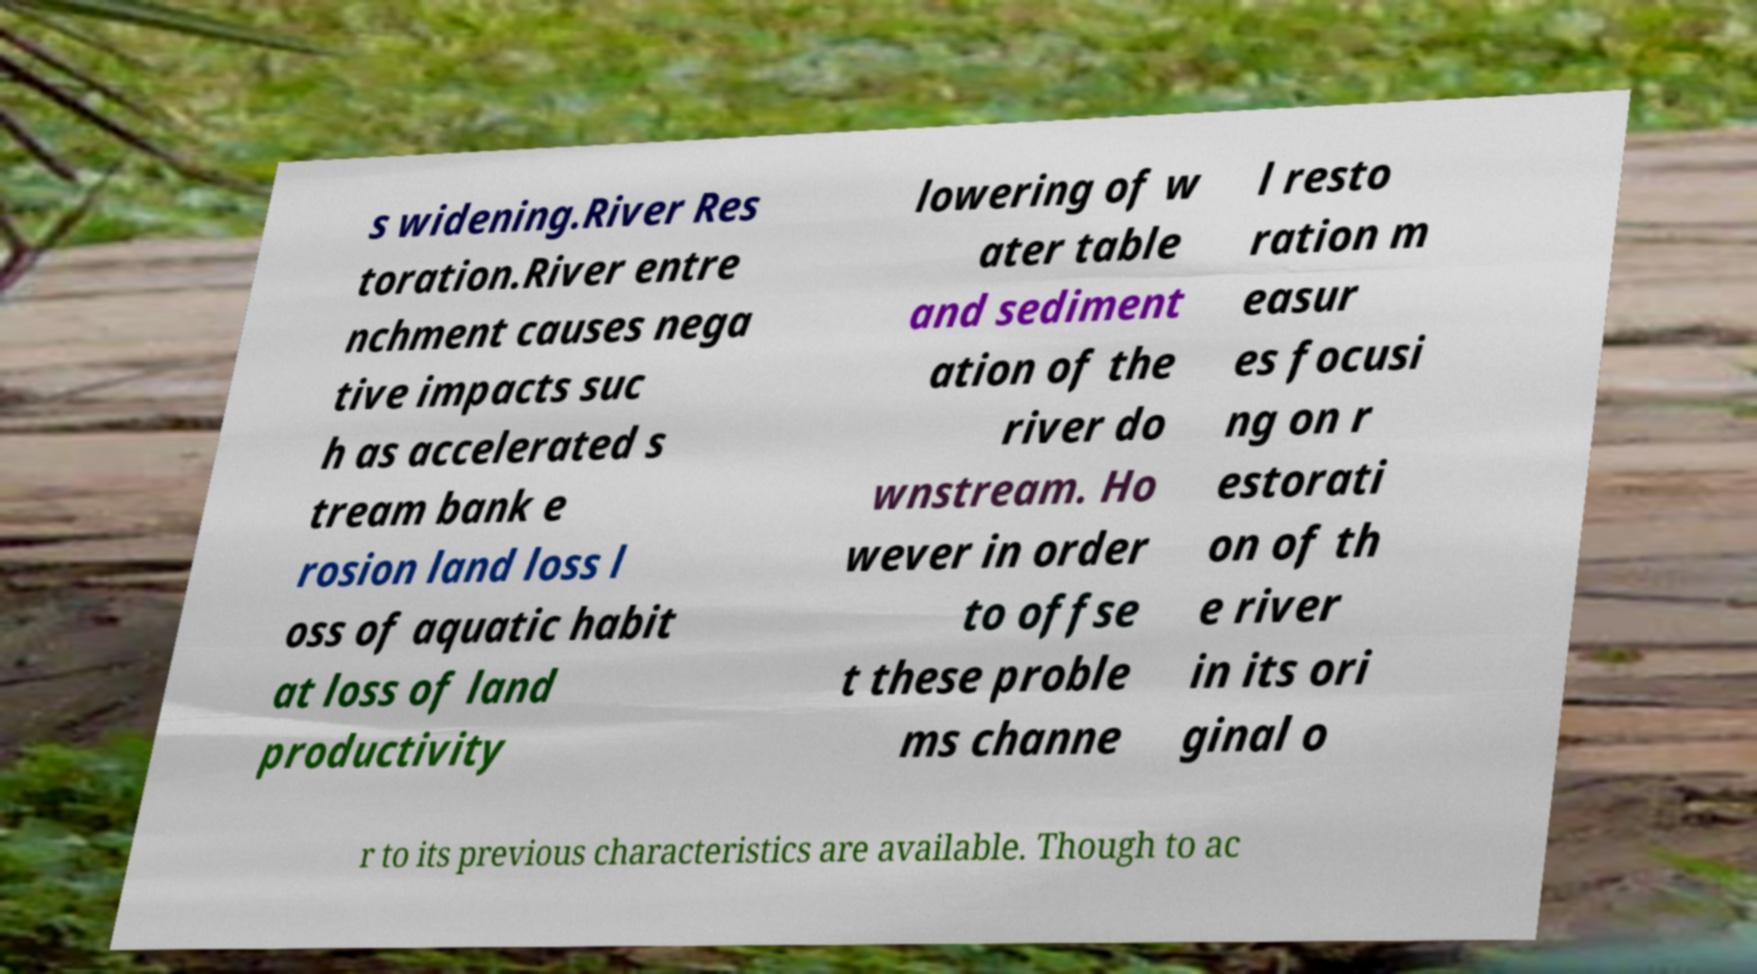Please identify and transcribe the text found in this image. s widening.River Res toration.River entre nchment causes nega tive impacts suc h as accelerated s tream bank e rosion land loss l oss of aquatic habit at loss of land productivity lowering of w ater table and sediment ation of the river do wnstream. Ho wever in order to offse t these proble ms channe l resto ration m easur es focusi ng on r estorati on of th e river in its ori ginal o r to its previous characteristics are available. Though to ac 